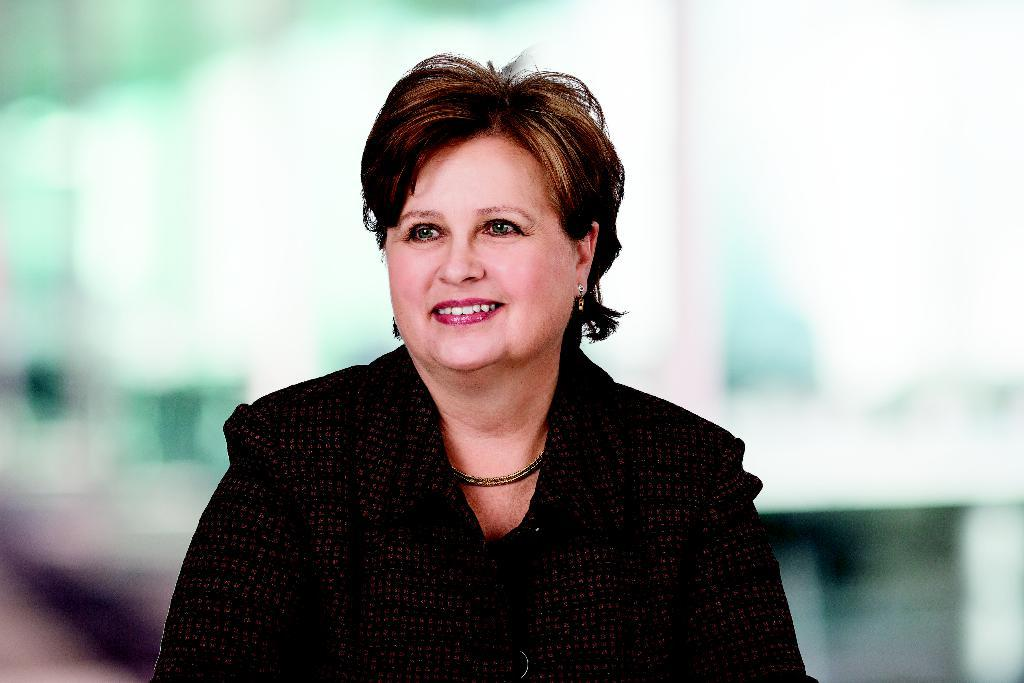Who is the main subject in the image? There is a woman in the image. What is the woman wearing? The woman is wearing a black jacket. What is the woman's facial expression in the image? The woman is smiling. What can be seen in the background of the image? There are other objects in the background of the image. How many balls are being juggled by the giants in the image? There are no giants or balls present in the image. 